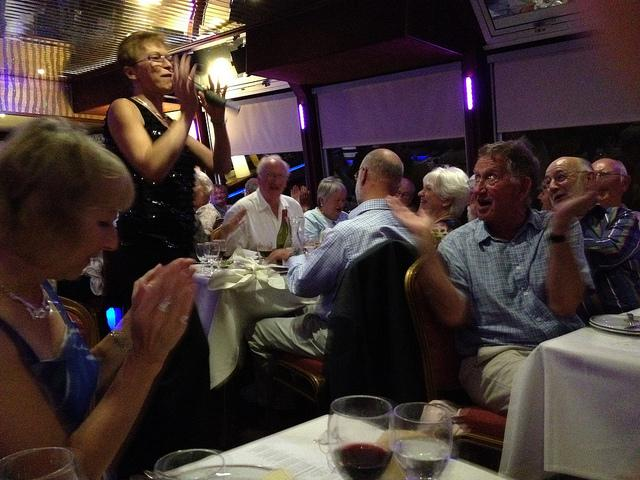What is the entertainment tonight for the people eating dinner? singer 